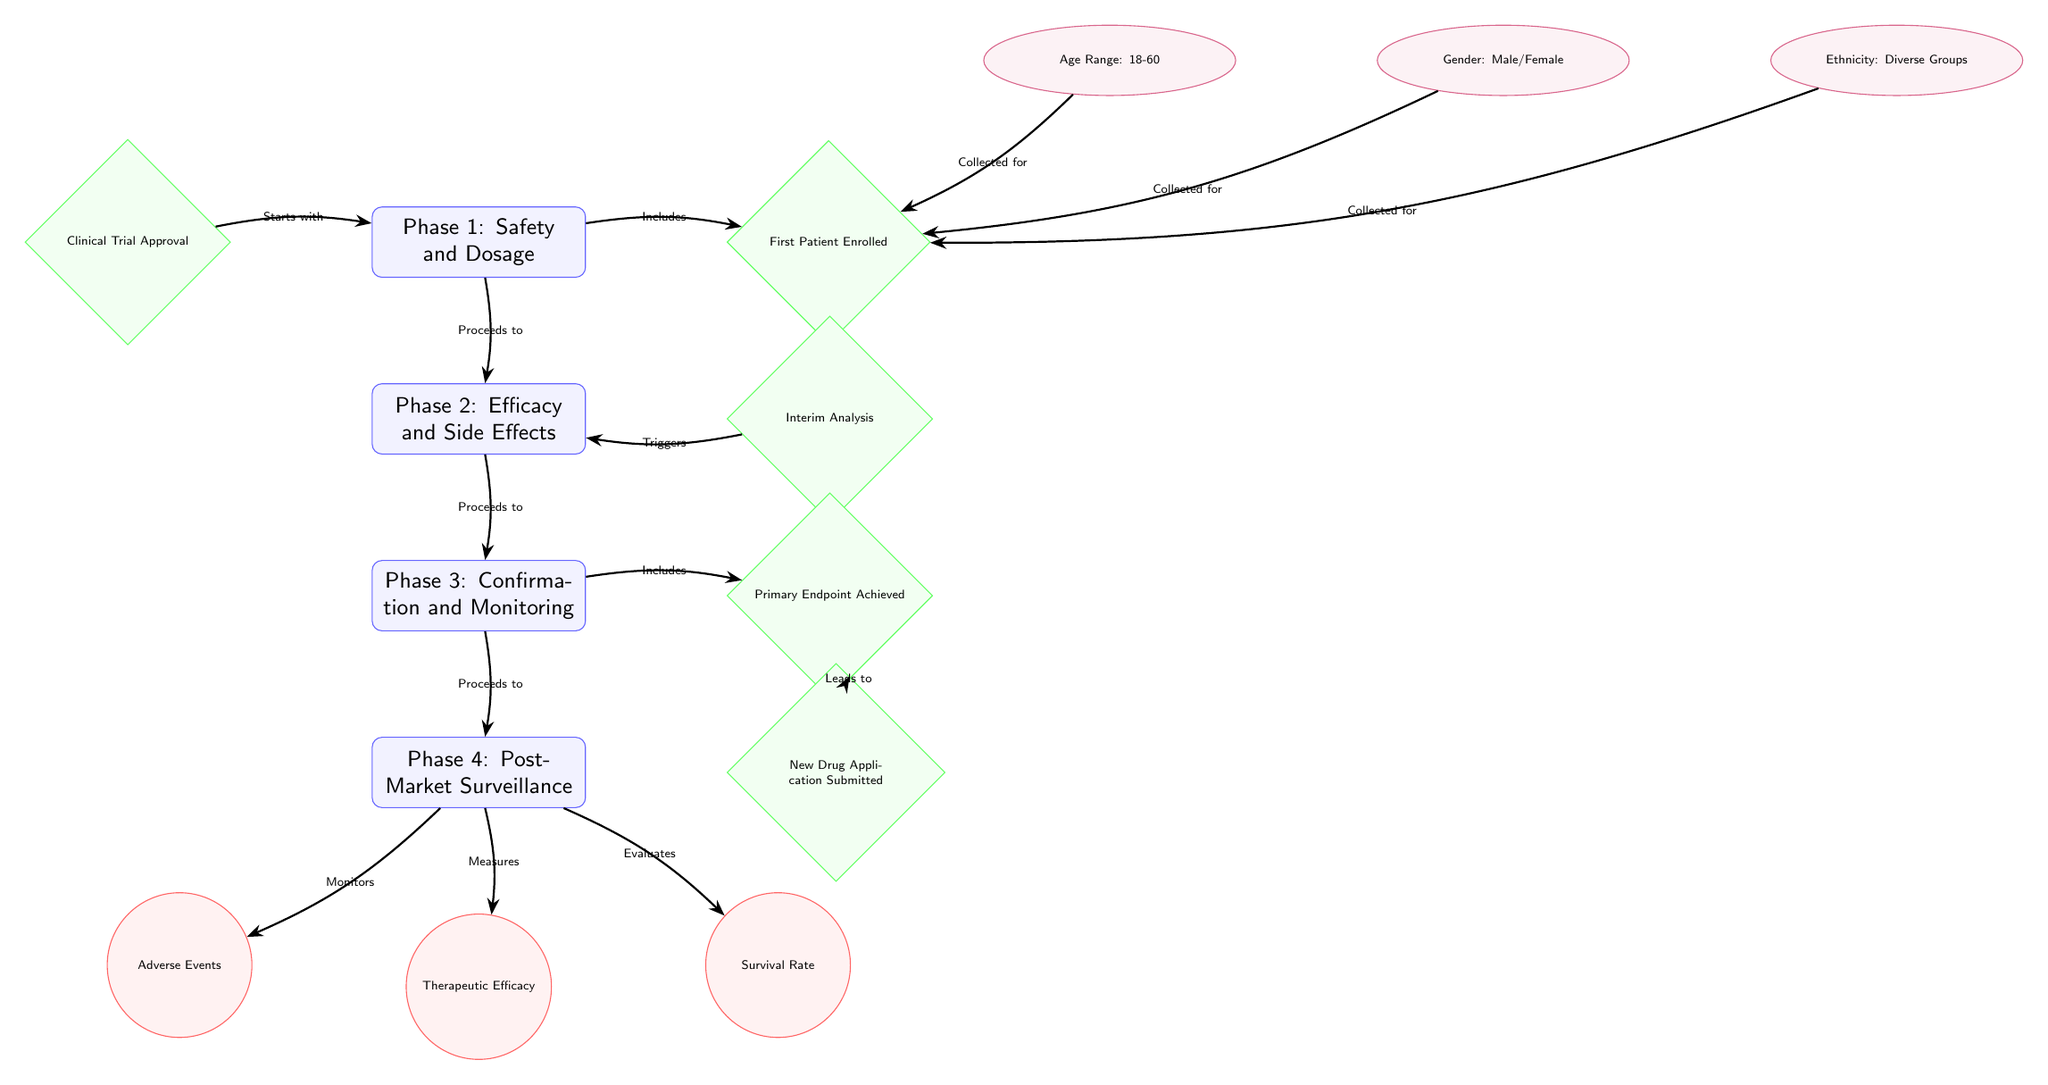What's the first phase of the clinical trial process? The diagram clearly lists the first phase, which is represented by the node labeled "Phase 1: Safety and Dosage".
Answer: Phase 1: Safety and Dosage How many phases are in the clinical trial process? By counting the nodes labeled as phases, we identify that there are a total of four phases in the clinical trial process.
Answer: 4 What is the primary outcome metric measured in Phase 4? The diagram’s outcome metrics indicate that "Survival Rate" is one of the metrics evaluated during Phase 4, specifically linked to that phase.
Answer: Survival Rate What triggers Phase 2 in the clinical trial? The connection marked "Triggers" indicates that "Interim Analysis" leads to the start of Phase 2, so we can identify this as the triggering event.
Answer: Interim Analysis Which demographic information is collected for the first patient enrolled? The diagram shows three pieces of demographic information collected for the first patient enrolled, specifically "Age Range: 18-60", "Gender: Male/Female", and "Ethnicity: Diverse Groups".
Answer: Age Range: 18-60, Gender: Male/Female, Ethnicity: Diverse Groups Which phase includes the milestone "Primary Endpoint Achieved"? Following the arrows in the diagram, we see that "Primary Endpoint Achieved" is included within Phase 3, as indicated by the connection labeled "Includes".
Answer: Phase 3 How do adverse events relate to Phase 4? The connection in the diagram shows that "Phase 4" monitors "Adverse Events", indicating a direct relationship between the phase and the outcome metric being monitored.
Answer: Monitors What is the last milestone in the multi-phase clinical trial process? The diagram shows "New Drug Application Submitted" as the final milestone occurring after Phase 4, making it the last one in the process.
Answer: New Drug Application Submitted What type of shape represents the key milestones in the diagram? The key milestones are represented by diamond-shaped nodes in the diagram, which is evident from their design.
Answer: Diamond 